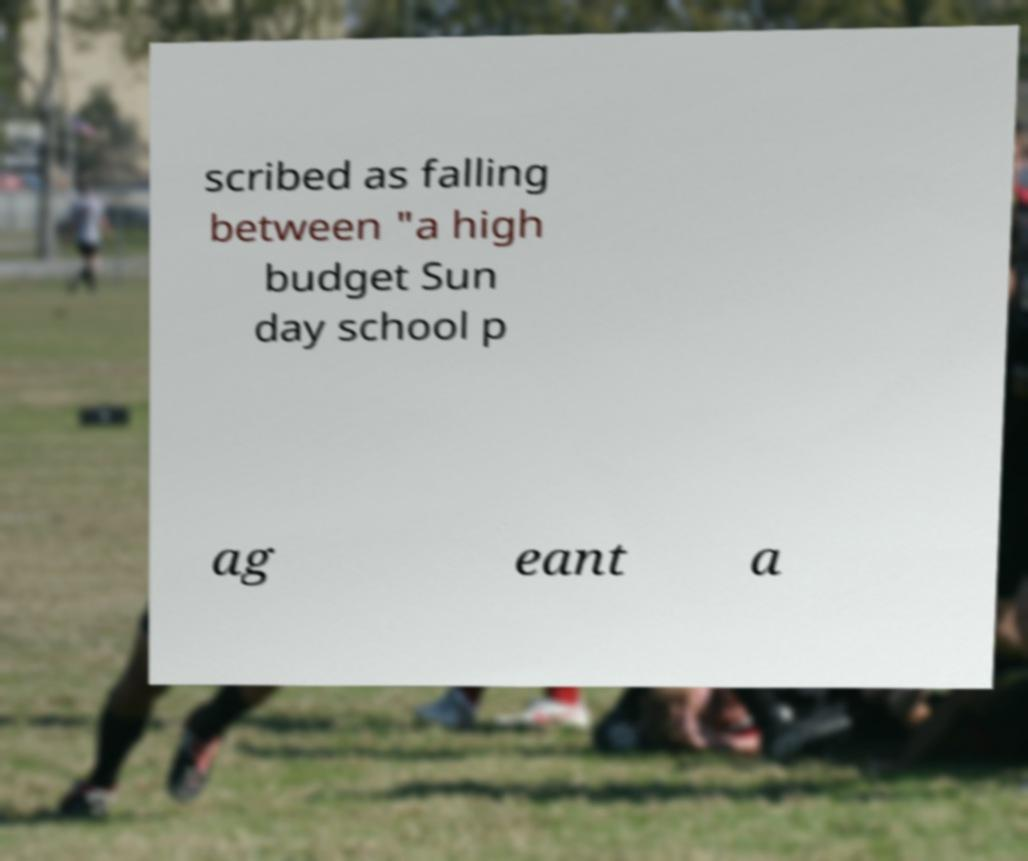Can you accurately transcribe the text from the provided image for me? scribed as falling between "a high budget Sun day school p ag eant a 